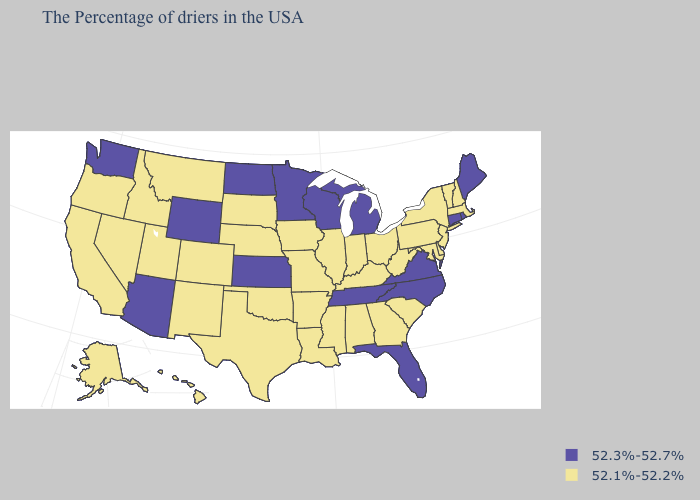Name the states that have a value in the range 52.1%-52.2%?
Write a very short answer. Massachusetts, New Hampshire, Vermont, New York, New Jersey, Delaware, Maryland, Pennsylvania, South Carolina, West Virginia, Ohio, Georgia, Kentucky, Indiana, Alabama, Illinois, Mississippi, Louisiana, Missouri, Arkansas, Iowa, Nebraska, Oklahoma, Texas, South Dakota, Colorado, New Mexico, Utah, Montana, Idaho, Nevada, California, Oregon, Alaska, Hawaii. What is the lowest value in the West?
Keep it brief. 52.1%-52.2%. What is the value of New Mexico?
Short answer required. 52.1%-52.2%. What is the lowest value in states that border Arkansas?
Concise answer only. 52.1%-52.2%. Does the first symbol in the legend represent the smallest category?
Keep it brief. No. What is the lowest value in the MidWest?
Concise answer only. 52.1%-52.2%. What is the value of Washington?
Give a very brief answer. 52.3%-52.7%. Name the states that have a value in the range 52.3%-52.7%?
Answer briefly. Maine, Rhode Island, Connecticut, Virginia, North Carolina, Florida, Michigan, Tennessee, Wisconsin, Minnesota, Kansas, North Dakota, Wyoming, Arizona, Washington. Which states hav the highest value in the South?
Write a very short answer. Virginia, North Carolina, Florida, Tennessee. Name the states that have a value in the range 52.1%-52.2%?
Keep it brief. Massachusetts, New Hampshire, Vermont, New York, New Jersey, Delaware, Maryland, Pennsylvania, South Carolina, West Virginia, Ohio, Georgia, Kentucky, Indiana, Alabama, Illinois, Mississippi, Louisiana, Missouri, Arkansas, Iowa, Nebraska, Oklahoma, Texas, South Dakota, Colorado, New Mexico, Utah, Montana, Idaho, Nevada, California, Oregon, Alaska, Hawaii. Does Illinois have the same value as South Carolina?
Answer briefly. Yes. What is the value of Maryland?
Concise answer only. 52.1%-52.2%. Name the states that have a value in the range 52.1%-52.2%?
Be succinct. Massachusetts, New Hampshire, Vermont, New York, New Jersey, Delaware, Maryland, Pennsylvania, South Carolina, West Virginia, Ohio, Georgia, Kentucky, Indiana, Alabama, Illinois, Mississippi, Louisiana, Missouri, Arkansas, Iowa, Nebraska, Oklahoma, Texas, South Dakota, Colorado, New Mexico, Utah, Montana, Idaho, Nevada, California, Oregon, Alaska, Hawaii. 